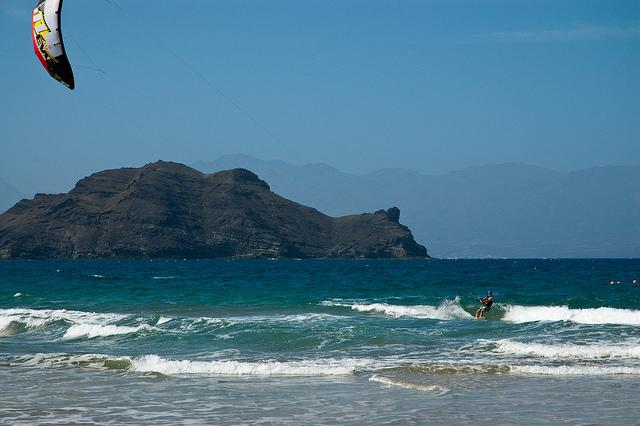What is he doing? Please explain your reasoning. wind surfing. It is evident by the rope showing that wind is used. 